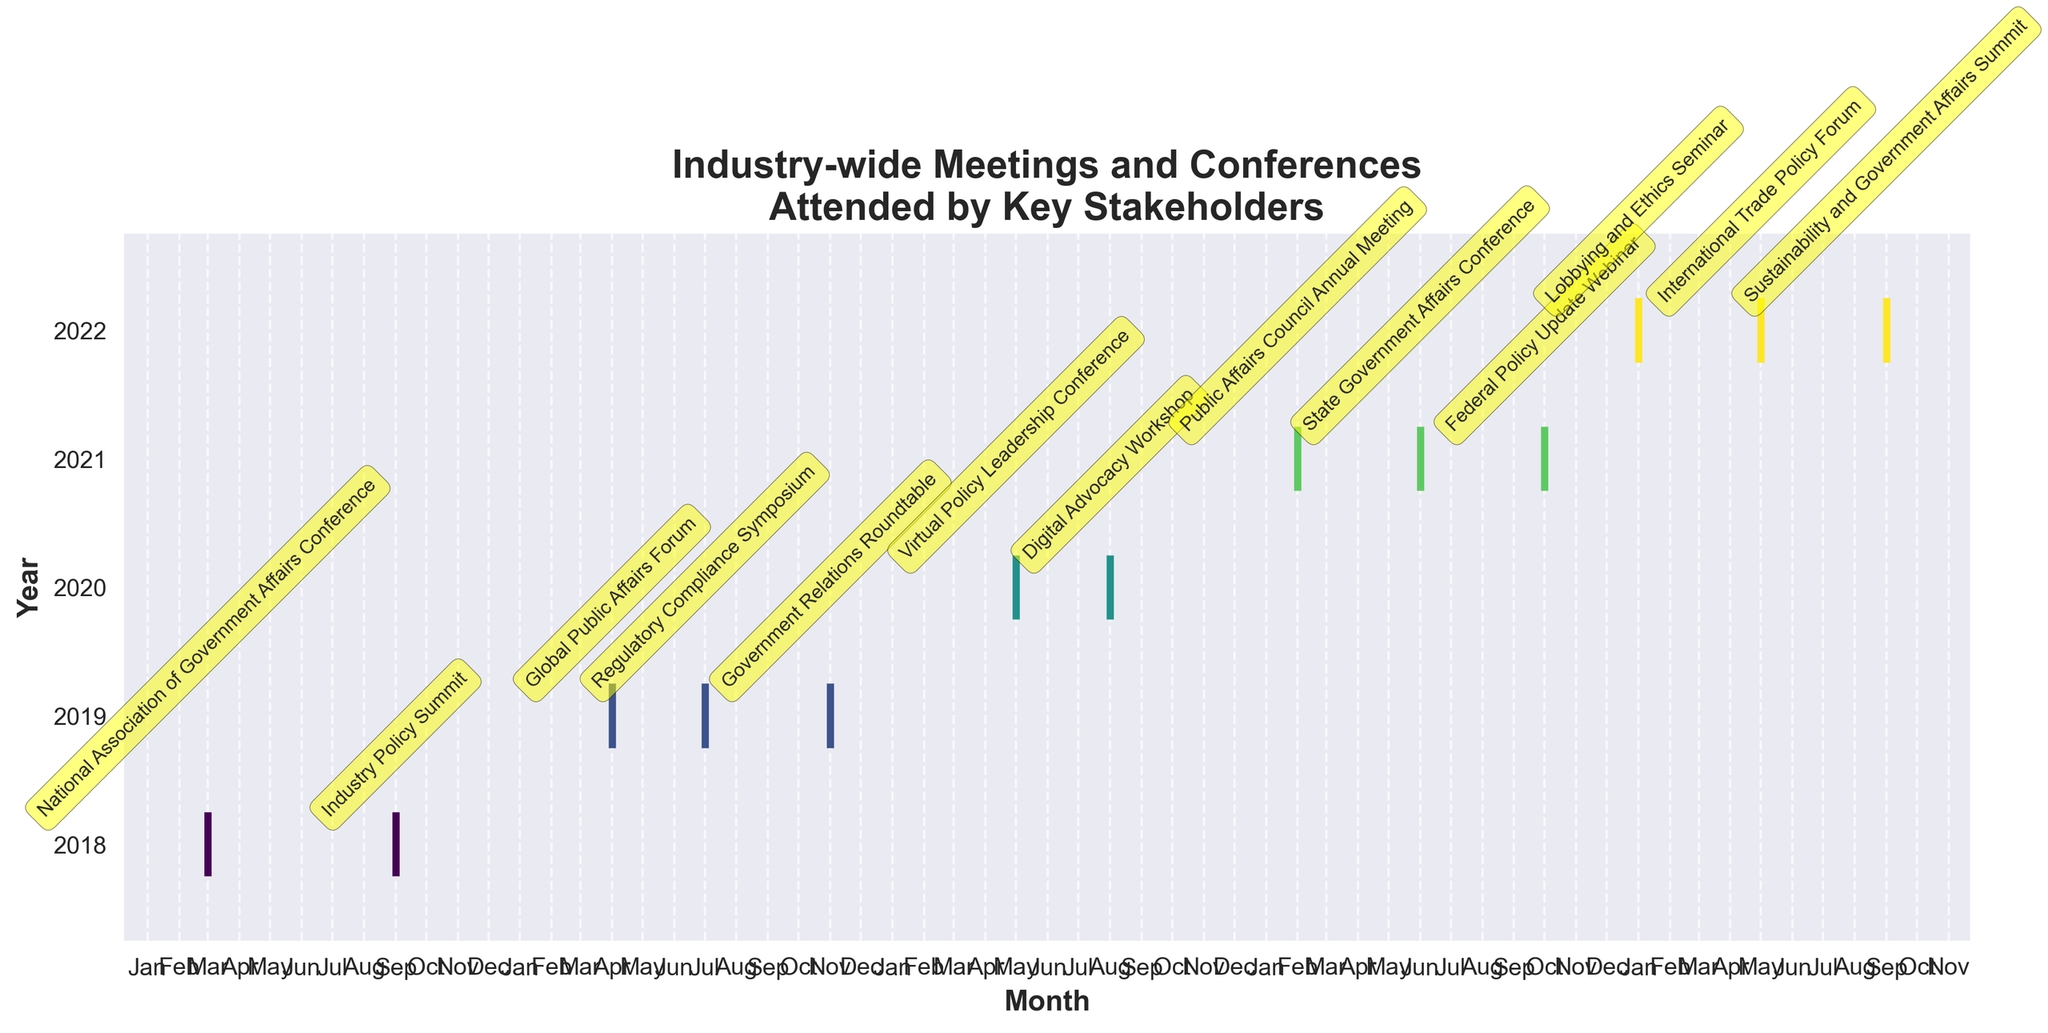What is the title of the figure? The title of the figure is located at the top and should capture the main topic of the visualized data.
Answer: Industry-wide Meetings and Conferences Attended by Key Stakeholders How many years of data are represented in the figure? Count the unique labels on the y-axis, as each one corresponds to a different year.
Answer: 5 Which year had the highest number of events and how many were there? Count the number of events visualized for each year and identify the year with the highest count.
Answer: 2019, with 3 events In which months of 2020 were industry-wide meetings or conferences held? Identify the markers along the timeline for 2020 and note their positions corresponding to the months.
Answer: May and August What is the central month for industry events in 2019? Look for the median position among the months with events in 2019. Since there are three events, the middle one is the median. The events are in April, July, and November, making July the central month.
Answer: July Compare the number of events in 2018 and 2021. Which year had more events? Count the events for both 2018 and 2021 and compare the totals.
Answer: 2021, with 3 events compared to 2 in 2018 Which event was held in March 2018? Locate the event annotation near March 2018 on the x-axis.
Answer: National Association of Government Affairs Conference What is the trend observed in the frequency of meetings or conferences from 2018 to 2022? Examine the number of events year by year to identify any increasing, decreasing, or stable patterns.
Answer: Generally increasing Identify one event that was held in October. Locate the annotations around October across all years to find the relevant event.
Answer: Federal Policy Update Webinar Calculate the average number of events per year over the 5-year period. Sum the total number of events and divide by the number of years (5). Total events are 2 (2018) + 3 (2019) + 2 (2020) + 3 (2021) + 3 (2022) = 13 events; 13/5 years = 2.6 events/year.
Answer: 2.6 